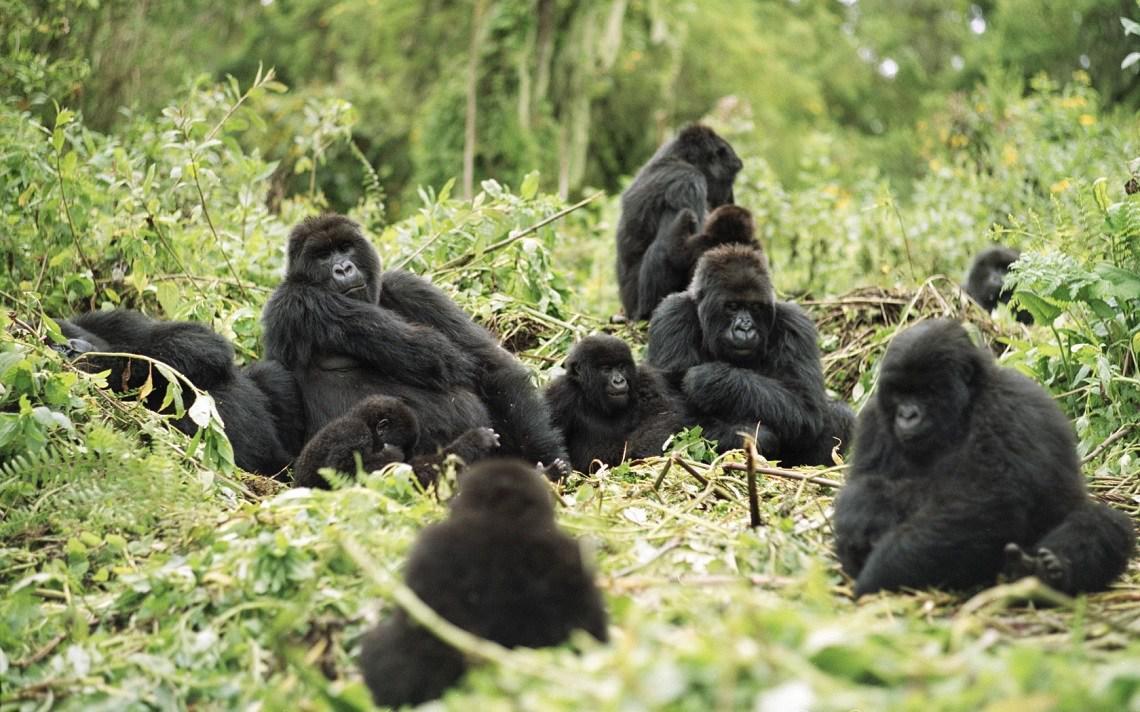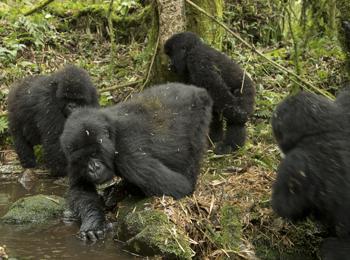The first image is the image on the left, the second image is the image on the right. For the images shown, is this caption "There are many gorillas sitting together in the jungle." true? Answer yes or no. Yes. The first image is the image on the left, the second image is the image on the right. For the images displayed, is the sentence "There are no more than seven gorillas." factually correct? Answer yes or no. No. 